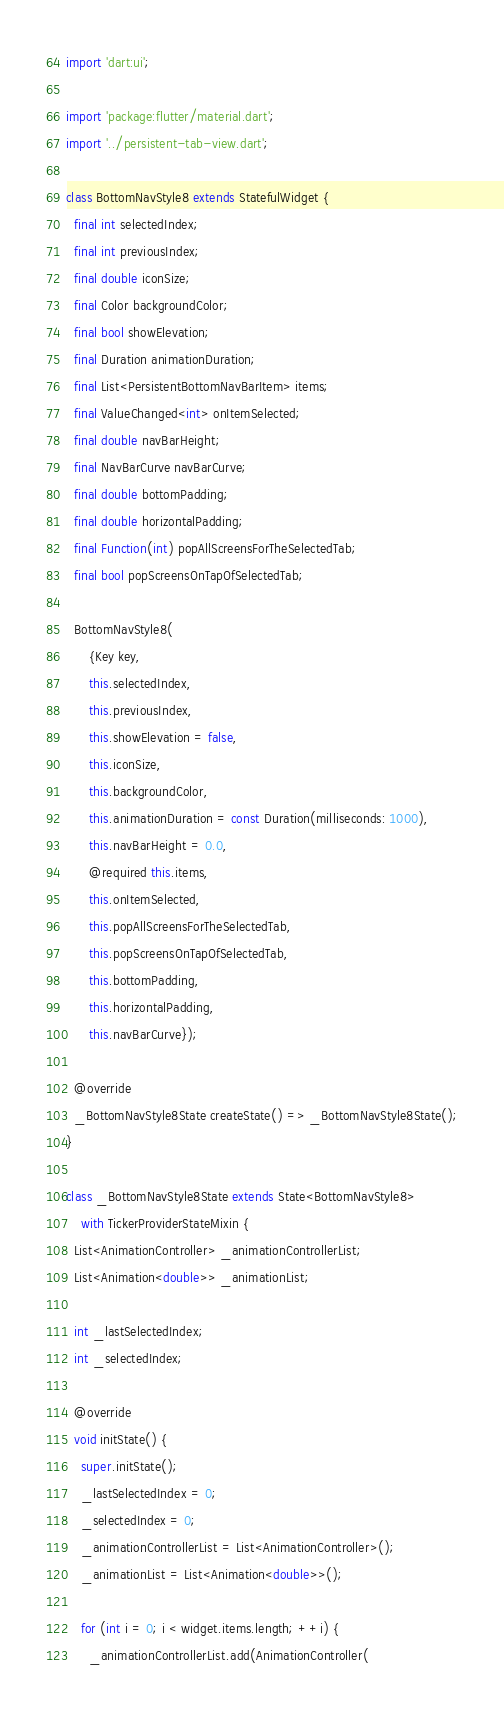Convert code to text. <code><loc_0><loc_0><loc_500><loc_500><_Dart_>import 'dart:ui';

import 'package:flutter/material.dart';
import '../persistent-tab-view.dart';

class BottomNavStyle8 extends StatefulWidget {
  final int selectedIndex;
  final int previousIndex;
  final double iconSize;
  final Color backgroundColor;
  final bool showElevation;
  final Duration animationDuration;
  final List<PersistentBottomNavBarItem> items;
  final ValueChanged<int> onItemSelected;
  final double navBarHeight;
  final NavBarCurve navBarCurve;
  final double bottomPadding;
  final double horizontalPadding;
  final Function(int) popAllScreensForTheSelectedTab;
  final bool popScreensOnTapOfSelectedTab;

  BottomNavStyle8(
      {Key key,
      this.selectedIndex,
      this.previousIndex,
      this.showElevation = false,
      this.iconSize,
      this.backgroundColor,
      this.animationDuration = const Duration(milliseconds: 1000),
      this.navBarHeight = 0.0,
      @required this.items,
      this.onItemSelected,
      this.popAllScreensForTheSelectedTab,
      this.popScreensOnTapOfSelectedTab,
      this.bottomPadding,
      this.horizontalPadding,
      this.navBarCurve});

  @override
  _BottomNavStyle8State createState() => _BottomNavStyle8State();
}

class _BottomNavStyle8State extends State<BottomNavStyle8>
    with TickerProviderStateMixin {
  List<AnimationController> _animationControllerList;
  List<Animation<double>> _animationList;

  int _lastSelectedIndex;
  int _selectedIndex;

  @override
  void initState() {
    super.initState();
    _lastSelectedIndex = 0;
    _selectedIndex = 0;
    _animationControllerList = List<AnimationController>();
    _animationList = List<Animation<double>>();

    for (int i = 0; i < widget.items.length; ++i) {
      _animationControllerList.add(AnimationController(</code> 